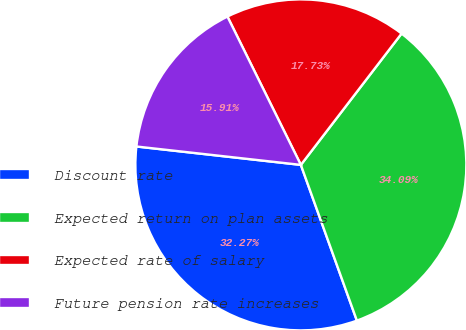<chart> <loc_0><loc_0><loc_500><loc_500><pie_chart><fcel>Discount rate<fcel>Expected return on plan assets<fcel>Expected rate of salary<fcel>Future pension rate increases<nl><fcel>32.27%<fcel>34.09%<fcel>17.73%<fcel>15.91%<nl></chart> 